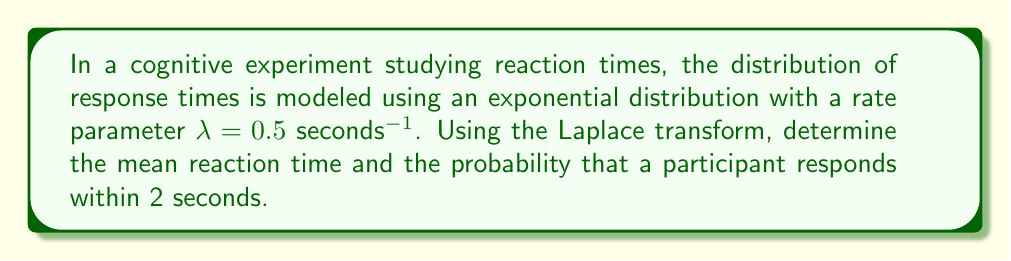Teach me how to tackle this problem. To solve this problem, we'll use the Laplace transform of the exponential distribution and its properties.

1. The probability density function (PDF) of an exponential distribution is:
   $$f(t) = \lambda e^{-\lambda t}, \quad t \geq 0$$

2. The Laplace transform of the exponential distribution is:
   $$F(s) = \mathcal{L}\{f(t)\} = \frac{\lambda}{s + \lambda}$$

3. To find the mean reaction time, we can use the property that the mean is equal to the negative of the derivative of the Laplace transform evaluated at s = 0:
   $$E[T] = -\frac{d}{ds}F(s)\bigg|_{s=0} = -\frac{d}{ds}\left(\frac{\lambda}{s + \lambda}\right)\bigg|_{s=0}$$
   $$= -\left(-\frac{\lambda}{(s + \lambda)^2}\right)\bigg|_{s=0} = \frac{\lambda}{(\lambda)^2} = \frac{1}{\lambda}$$

   Substituting $\lambda = 0.5$ seconds$^{-1}$:
   $$E[T] = \frac{1}{0.5} = 2 \text{ seconds}$$

4. To find the probability that a participant responds within 2 seconds, we need to calculate:
   $$P(T \leq 2) = 1 - P(T > 2) = 1 - e^{-\lambda t}$$

   Substituting $\lambda = 0.5$ seconds$^{-1}$ and $t = 2$ seconds:
   $$P(T \leq 2) = 1 - e^{-0.5 \cdot 2} = 1 - e^{-1} \approx 0.6321$$
Answer: The mean reaction time is 2 seconds, and the probability that a participant responds within 2 seconds is approximately 0.6321 or 63.21%. 